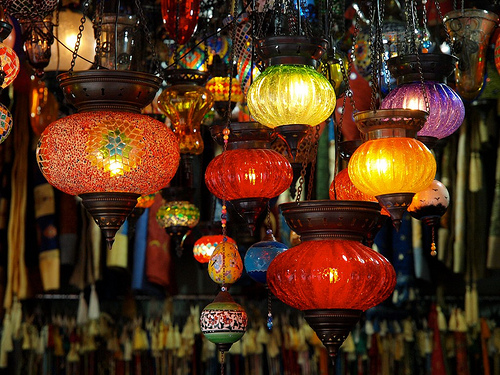<image>
Can you confirm if the yellow light is behind the purple light? No. The yellow light is not behind the purple light. From this viewpoint, the yellow light appears to be positioned elsewhere in the scene. 